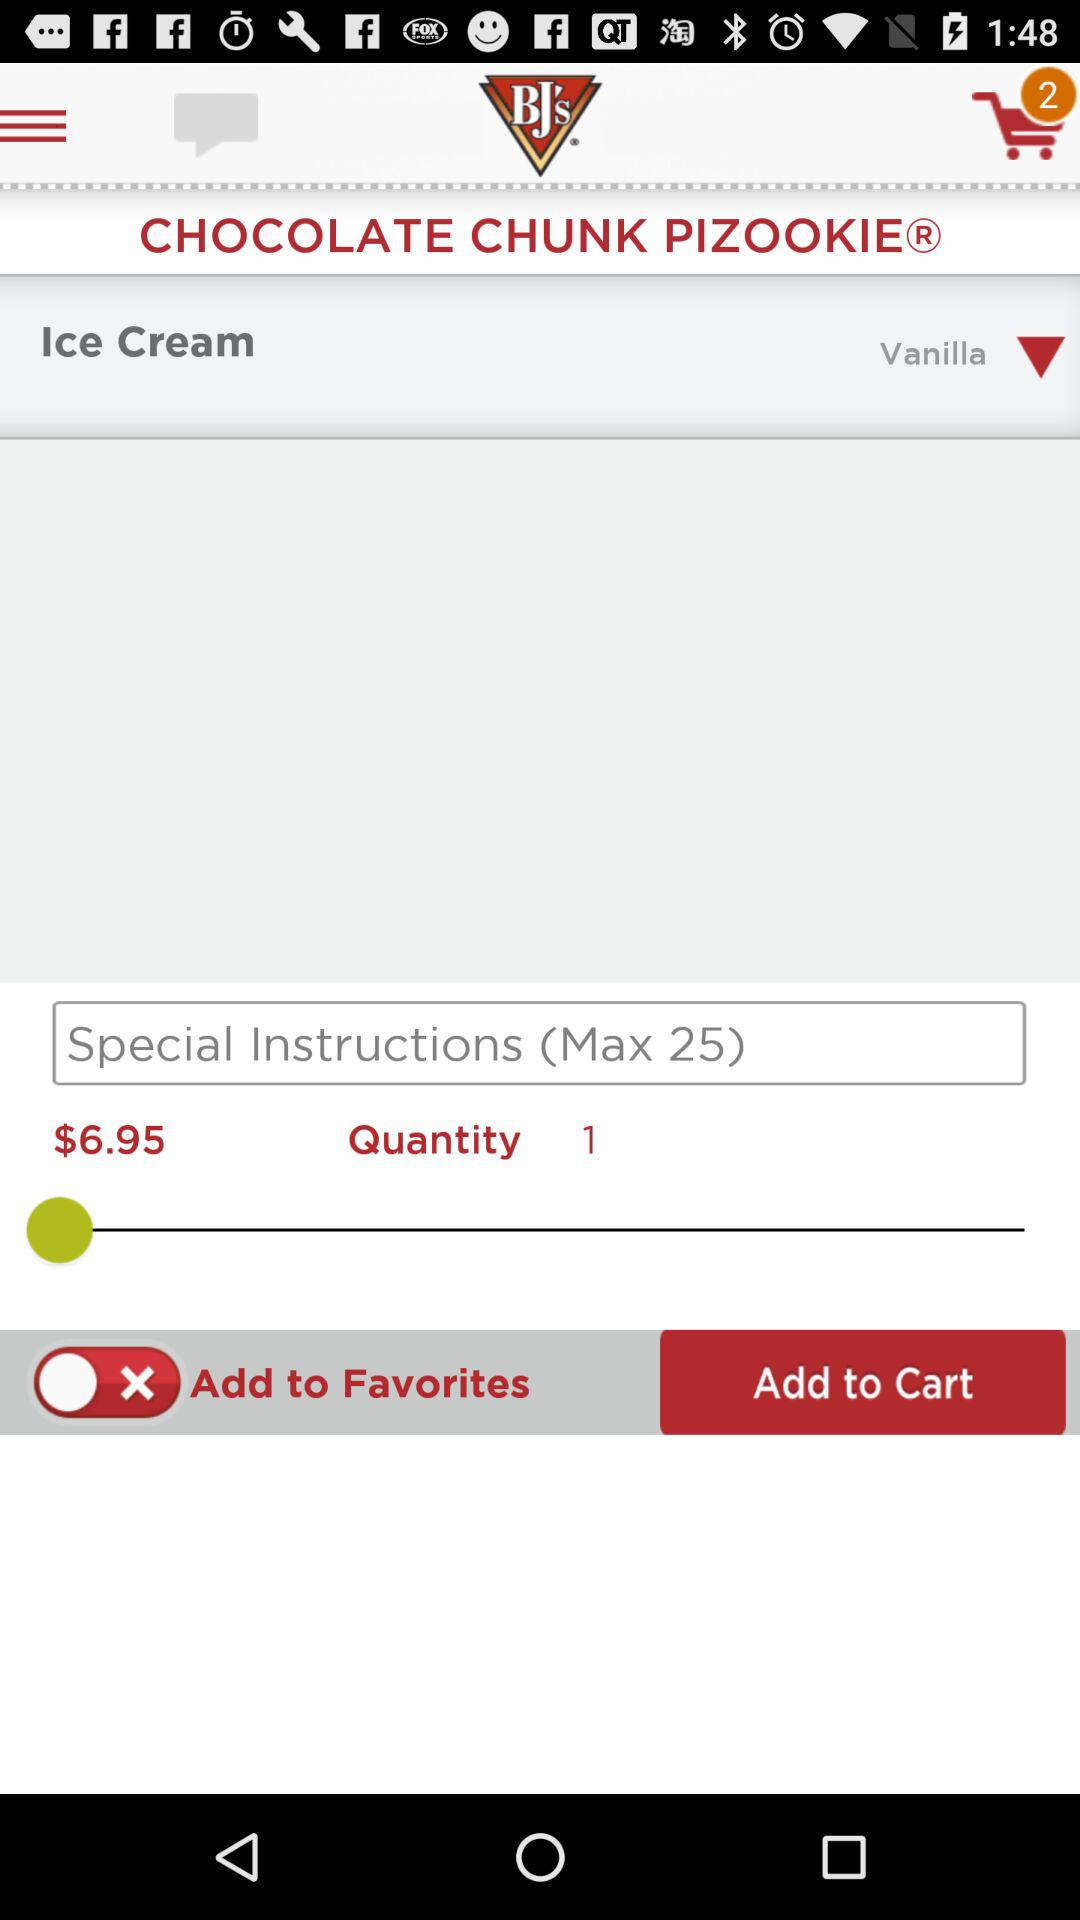How many items are in the cart? There are 2 items in the cart. 